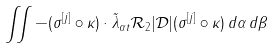<formula> <loc_0><loc_0><loc_500><loc_500>\iint - ( \sigma ^ { [ j ] } \circ \kappa ) \cdot \tilde { \lambda } _ { \alpha t } \mathcal { R } _ { 2 } | \mathcal { D } | ( \sigma ^ { [ j ] } \circ \kappa ) \, d \alpha \, d \beta</formula> 